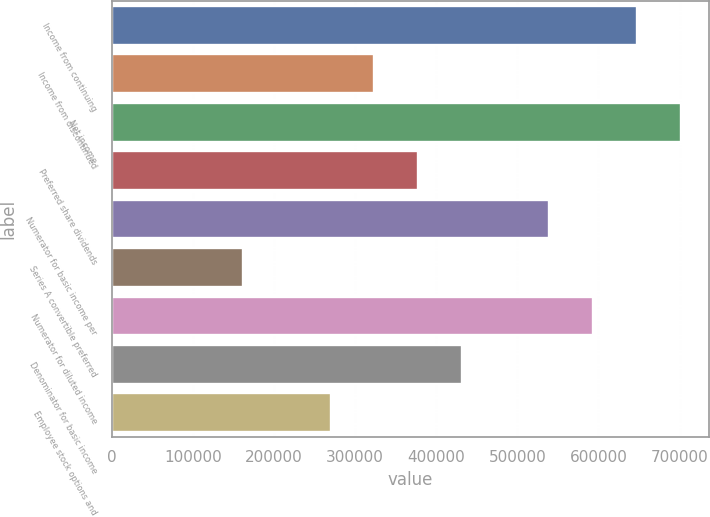<chart> <loc_0><loc_0><loc_500><loc_500><bar_chart><fcel>Income from continuing<fcel>Income from discontinued<fcel>Net income<fcel>Preferred share dividends<fcel>Numerator for basic income per<fcel>Series A convertible preferred<fcel>Numerator for diluted income<fcel>Denominator for basic income<fcel>Employee stock options and<nl><fcel>647525<fcel>323763<fcel>701485<fcel>377723<fcel>539604<fcel>161881<fcel>593564<fcel>431683<fcel>269802<nl></chart> 